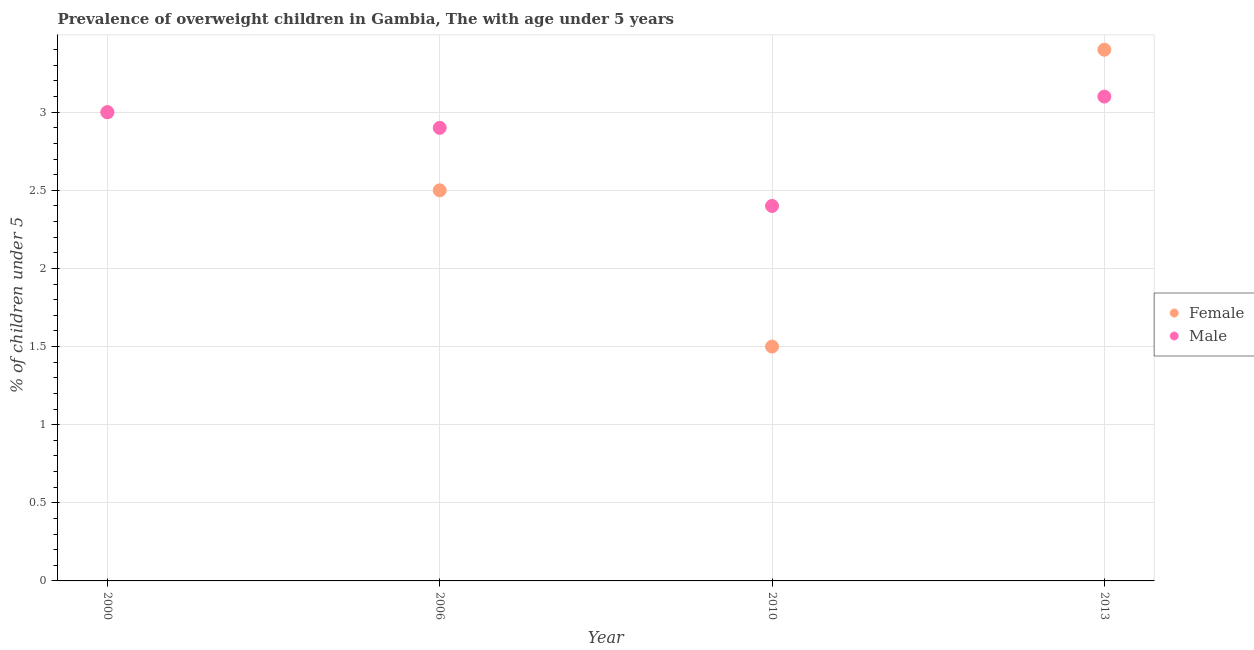How many different coloured dotlines are there?
Make the answer very short. 2. Is the number of dotlines equal to the number of legend labels?
Make the answer very short. Yes. What is the percentage of obese female children in 2006?
Make the answer very short. 2.5. Across all years, what is the maximum percentage of obese male children?
Give a very brief answer. 3.1. What is the total percentage of obese male children in the graph?
Offer a very short reply. 11.4. What is the difference between the percentage of obese male children in 2000 and that in 2006?
Your response must be concise. 0.1. What is the average percentage of obese male children per year?
Your answer should be very brief. 2.85. In the year 2013, what is the difference between the percentage of obese female children and percentage of obese male children?
Your answer should be very brief. 0.3. What is the ratio of the percentage of obese female children in 2010 to that in 2013?
Your answer should be compact. 0.44. Is the percentage of obese female children in 2006 less than that in 2010?
Provide a short and direct response. No. What is the difference between the highest and the second highest percentage of obese female children?
Your response must be concise. 0.4. What is the difference between the highest and the lowest percentage of obese male children?
Offer a very short reply. 0.7. In how many years, is the percentage of obese male children greater than the average percentage of obese male children taken over all years?
Your answer should be very brief. 3. Does the percentage of obese female children monotonically increase over the years?
Your answer should be very brief. No. How many dotlines are there?
Provide a succinct answer. 2. How many years are there in the graph?
Offer a terse response. 4. Where does the legend appear in the graph?
Keep it short and to the point. Center right. How many legend labels are there?
Your answer should be compact. 2. What is the title of the graph?
Provide a short and direct response. Prevalence of overweight children in Gambia, The with age under 5 years. Does "Adolescent fertility rate" appear as one of the legend labels in the graph?
Provide a short and direct response. No. What is the label or title of the Y-axis?
Offer a very short reply.  % of children under 5. What is the  % of children under 5 of Female in 2000?
Your answer should be very brief. 3. What is the  % of children under 5 in Male in 2006?
Your answer should be compact. 2.9. What is the  % of children under 5 of Male in 2010?
Your response must be concise. 2.4. What is the  % of children under 5 of Female in 2013?
Offer a very short reply. 3.4. What is the  % of children under 5 in Male in 2013?
Your answer should be very brief. 3.1. Across all years, what is the maximum  % of children under 5 of Female?
Give a very brief answer. 3.4. Across all years, what is the maximum  % of children under 5 of Male?
Provide a short and direct response. 3.1. Across all years, what is the minimum  % of children under 5 in Male?
Your answer should be compact. 2.4. What is the total  % of children under 5 of Female in the graph?
Provide a succinct answer. 10.4. What is the difference between the  % of children under 5 in Male in 2000 and that in 2006?
Give a very brief answer. 0.1. What is the difference between the  % of children under 5 in Female in 2006 and that in 2013?
Offer a terse response. -0.9. What is the difference between the  % of children under 5 of Male in 2006 and that in 2013?
Provide a short and direct response. -0.2. What is the difference between the  % of children under 5 in Female in 2010 and that in 2013?
Your response must be concise. -1.9. What is the difference between the  % of children under 5 in Male in 2010 and that in 2013?
Provide a succinct answer. -0.7. What is the difference between the  % of children under 5 in Female in 2000 and the  % of children under 5 in Male in 2006?
Offer a terse response. 0.1. What is the difference between the  % of children under 5 of Female in 2000 and the  % of children under 5 of Male in 2013?
Offer a terse response. -0.1. What is the difference between the  % of children under 5 of Female in 2010 and the  % of children under 5 of Male in 2013?
Your answer should be very brief. -1.6. What is the average  % of children under 5 of Female per year?
Provide a short and direct response. 2.6. What is the average  % of children under 5 of Male per year?
Provide a short and direct response. 2.85. In the year 2000, what is the difference between the  % of children under 5 in Female and  % of children under 5 in Male?
Make the answer very short. 0. In the year 2006, what is the difference between the  % of children under 5 in Female and  % of children under 5 in Male?
Your response must be concise. -0.4. In the year 2010, what is the difference between the  % of children under 5 in Female and  % of children under 5 in Male?
Your response must be concise. -0.9. What is the ratio of the  % of children under 5 of Male in 2000 to that in 2006?
Offer a terse response. 1.03. What is the ratio of the  % of children under 5 of Female in 2000 to that in 2010?
Give a very brief answer. 2. What is the ratio of the  % of children under 5 in Male in 2000 to that in 2010?
Your answer should be very brief. 1.25. What is the ratio of the  % of children under 5 in Female in 2000 to that in 2013?
Offer a terse response. 0.88. What is the ratio of the  % of children under 5 of Male in 2000 to that in 2013?
Offer a terse response. 0.97. What is the ratio of the  % of children under 5 of Male in 2006 to that in 2010?
Your response must be concise. 1.21. What is the ratio of the  % of children under 5 in Female in 2006 to that in 2013?
Ensure brevity in your answer.  0.74. What is the ratio of the  % of children under 5 in Male in 2006 to that in 2013?
Make the answer very short. 0.94. What is the ratio of the  % of children under 5 in Female in 2010 to that in 2013?
Your response must be concise. 0.44. What is the ratio of the  % of children under 5 in Male in 2010 to that in 2013?
Your response must be concise. 0.77. What is the difference between the highest and the second highest  % of children under 5 in Female?
Your answer should be very brief. 0.4. 